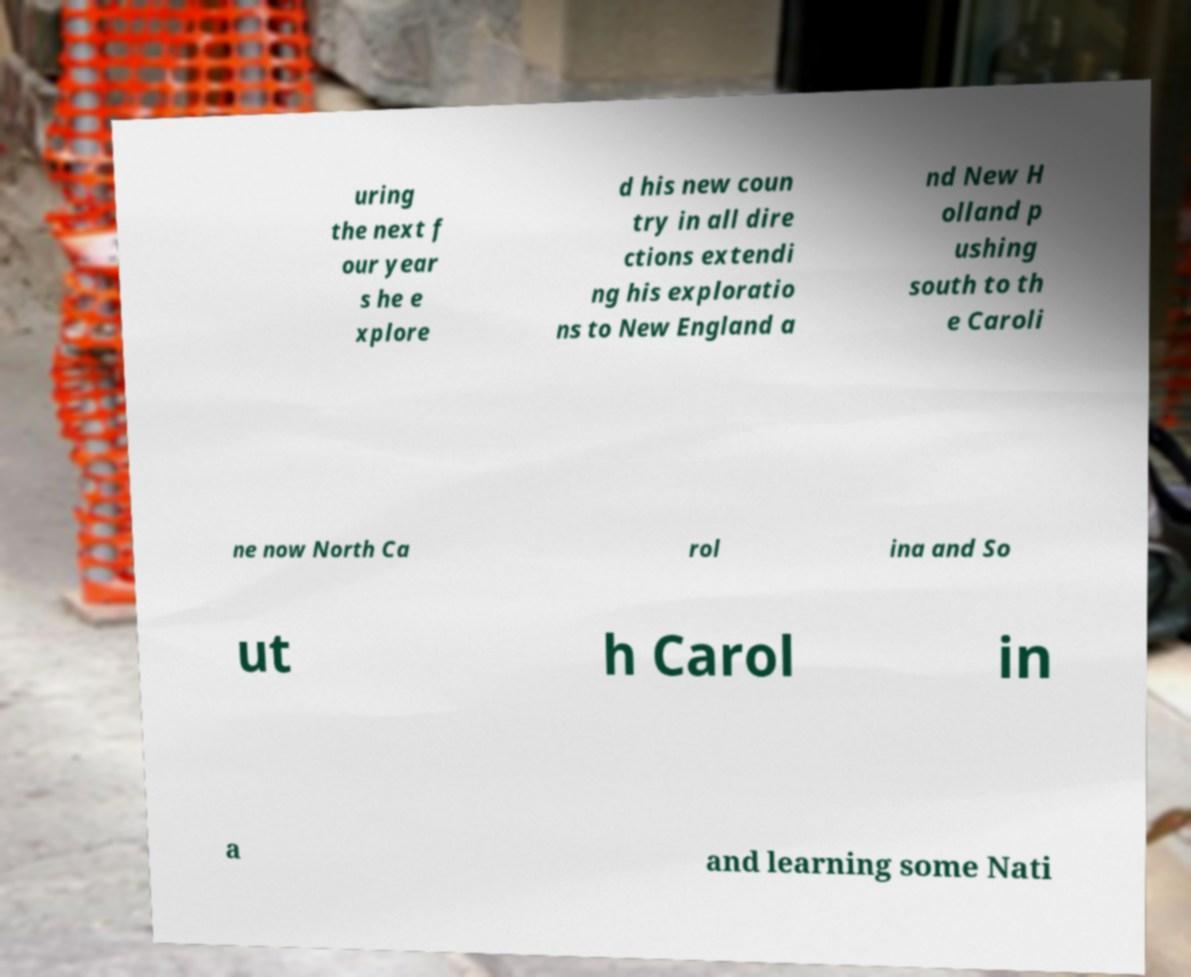Could you extract and type out the text from this image? uring the next f our year s he e xplore d his new coun try in all dire ctions extendi ng his exploratio ns to New England a nd New H olland p ushing south to th e Caroli ne now North Ca rol ina and So ut h Carol in a and learning some Nati 